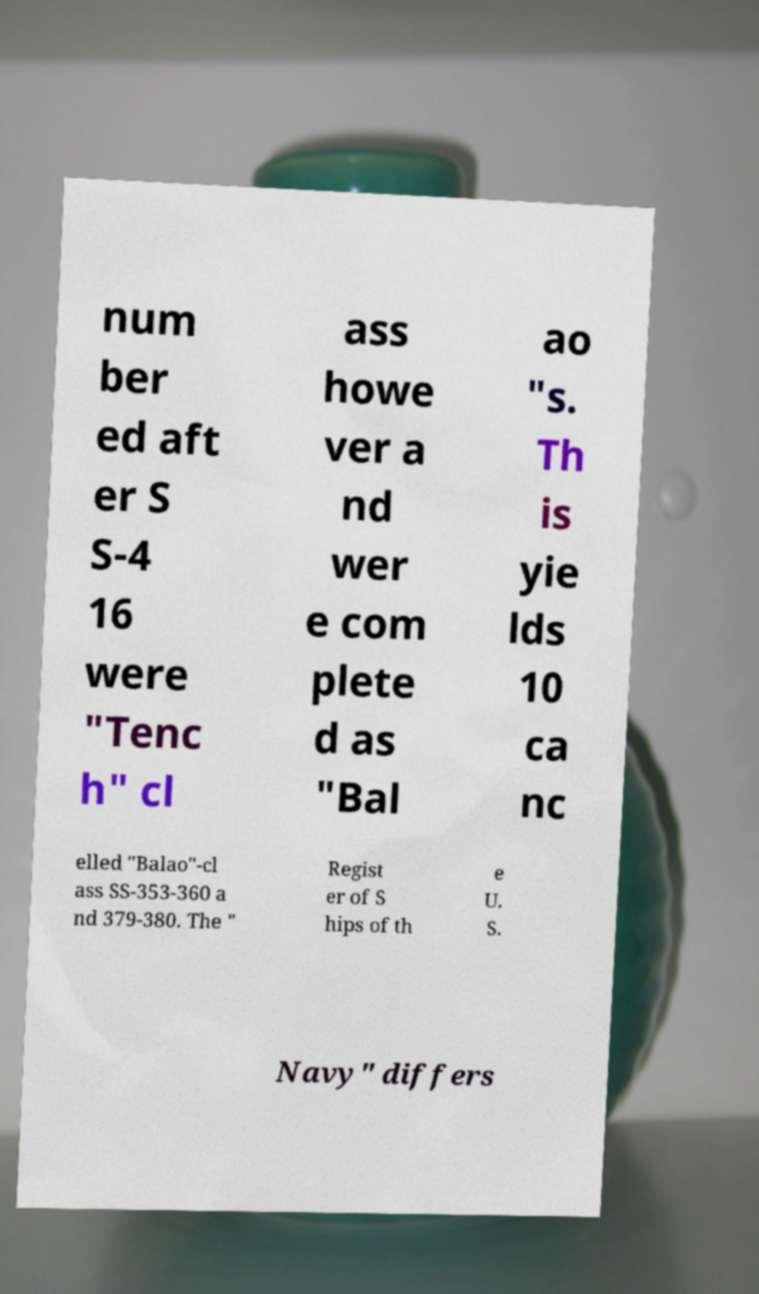For documentation purposes, I need the text within this image transcribed. Could you provide that? num ber ed aft er S S-4 16 were "Tenc h" cl ass howe ver a nd wer e com plete d as "Bal ao "s. Th is yie lds 10 ca nc elled "Balao"-cl ass SS-353-360 a nd 379-380. The " Regist er of S hips of th e U. S. Navy" differs 